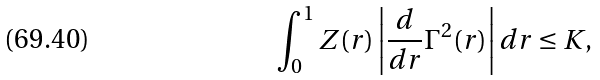Convert formula to latex. <formula><loc_0><loc_0><loc_500><loc_500>\int _ { 0 } ^ { 1 } Z ( r ) \left | \frac { d } { d r } \Gamma ^ { 2 } ( r ) \right | d r \leq K ,</formula> 